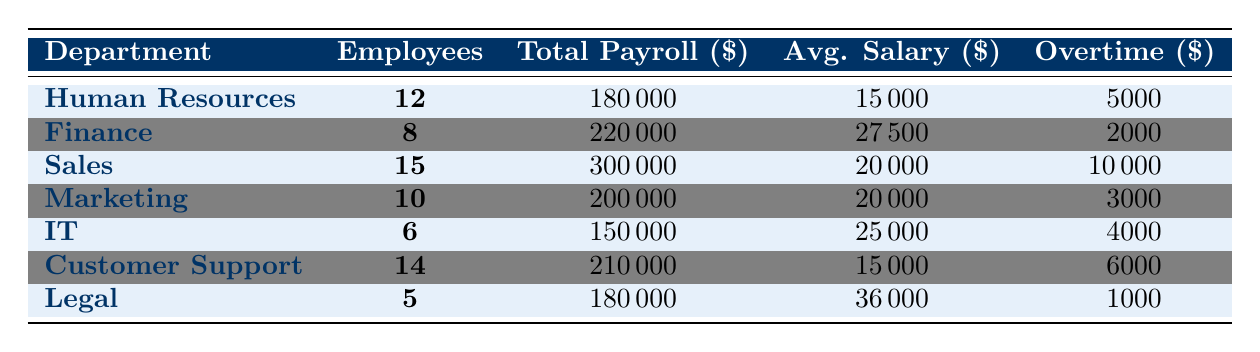What is the total payroll expense for the Sales department? The Sales department has a total payroll expense listed directly in the table, which is $300,000.
Answer: $300,000 How many employees are there in the Finance department? The number of employees in the Finance department is provided in the table, which is 8.
Answer: 8 What is the average salary of employees in the Legal department? The average salary for the Legal department is clearly stated in the table, which is $36,000.
Answer: $36,000 Which department has the highest total payroll expense? By comparing the total payroll expenses listed for each department, Sales has the highest expense at $300,000.
Answer: Sales What is the combined total payroll expense for the IT and Marketing departments? The total payroll expense for IT is $150,000 and for Marketing it is $200,000. So, the combined total is $150,000 + $200,000 = $350,000.
Answer: $350,000 Is the average salary of the Customer Support department higher than that of Human Resources? The average salary for Customer Support is $15,000, while for Human Resources it is also $15,000. Since they are equal, the statement is false.
Answer: No Which department has the least number of employees? By checking the number of employees listed for each department, the Legal department has the least with 5 employees.
Answer: Legal What is the total amount spent on overtime expenses across all departments? The table lists the overtime expenses for each department: $5,000 (HR) + $2,000 (Finance) + $10,000 (Sales) + $3,000 (Marketing) + $4,000 (IT) + $6,000 (Customer Support) + $1,000 (Legal) = $31,000.
Answer: $31,000 Which department spends the most on overtime? By reviewing the overtime expenses for each department, Sales has the highest overtime expense at $10,000.
Answer: Sales If the average salary of Finance employees is $27,500, what is the total payroll expense per employee in that department? The total payroll expense for Finance is $220,000, and with 8 employees, the total payroll expense per employee is $220,000 / 8 = $27,500, so the statement is accurate.
Answer: $27,500 What department has a payroll expense that is closest to $200,000? Looking at the total payroll expenses, Marketing has a total of $200,000, which matches exactly. Finance is $220,000, while IT is $150,000, making Marketing the closest.
Answer: Marketing 